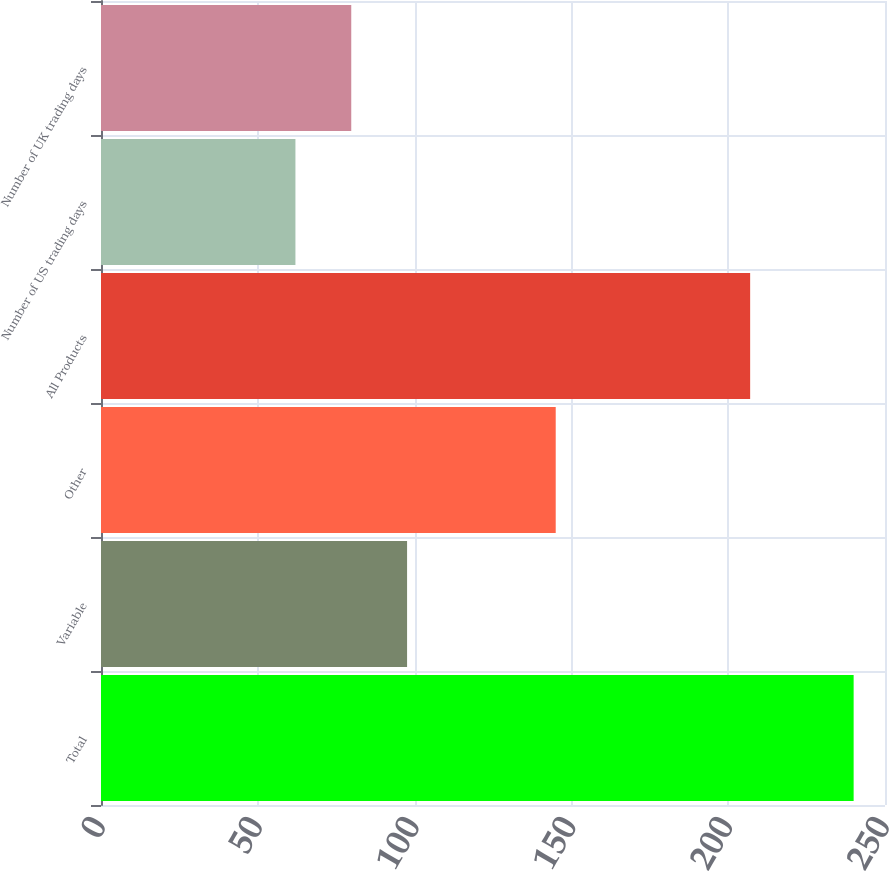Convert chart. <chart><loc_0><loc_0><loc_500><loc_500><bar_chart><fcel>Total<fcel>Variable<fcel>Other<fcel>All Products<fcel>Number of US trading days<fcel>Number of UK trading days<nl><fcel>240<fcel>97.6<fcel>145<fcel>207<fcel>62<fcel>79.8<nl></chart> 